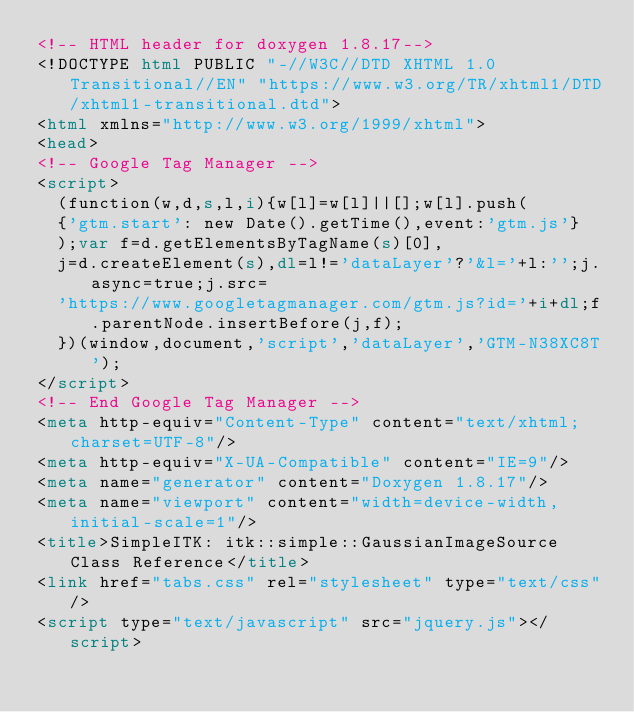Convert code to text. <code><loc_0><loc_0><loc_500><loc_500><_HTML_><!-- HTML header for doxygen 1.8.17-->
<!DOCTYPE html PUBLIC "-//W3C//DTD XHTML 1.0 Transitional//EN" "https://www.w3.org/TR/xhtml1/DTD/xhtml1-transitional.dtd">
<html xmlns="http://www.w3.org/1999/xhtml">
<head>
<!-- Google Tag Manager -->
<script>
  (function(w,d,s,l,i){w[l]=w[l]||[];w[l].push(
  {'gtm.start': new Date().getTime(),event:'gtm.js'}
  );var f=d.getElementsByTagName(s)[0],
  j=d.createElement(s),dl=l!='dataLayer'?'&l='+l:'';j.async=true;j.src=
  'https://www.googletagmanager.com/gtm.js?id='+i+dl;f.parentNode.insertBefore(j,f);
  })(window,document,'script','dataLayer','GTM-N38XC8T');
</script>
<!-- End Google Tag Manager -->
<meta http-equiv="Content-Type" content="text/xhtml;charset=UTF-8"/>
<meta http-equiv="X-UA-Compatible" content="IE=9"/>
<meta name="generator" content="Doxygen 1.8.17"/>
<meta name="viewport" content="width=device-width, initial-scale=1"/>
<title>SimpleITK: itk::simple::GaussianImageSource Class Reference</title>
<link href="tabs.css" rel="stylesheet" type="text/css"/>
<script type="text/javascript" src="jquery.js"></script></code> 